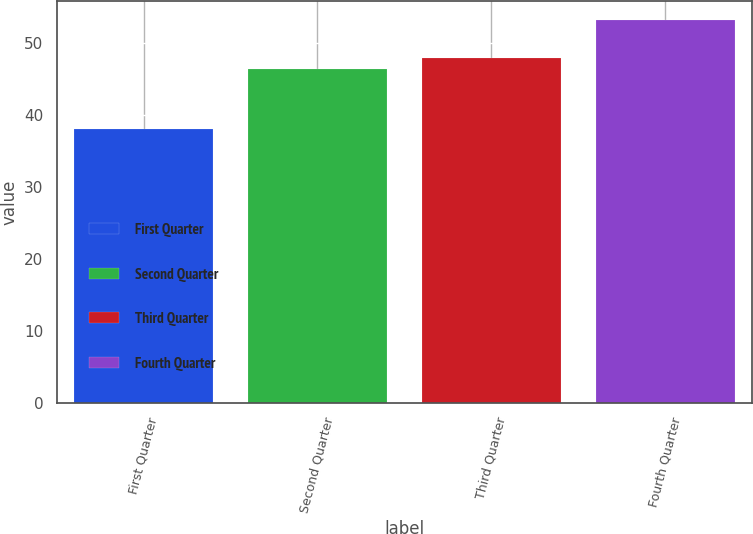Convert chart. <chart><loc_0><loc_0><loc_500><loc_500><bar_chart><fcel>First Quarter<fcel>Second Quarter<fcel>Third Quarter<fcel>Fourth Quarter<nl><fcel>37.99<fcel>46.41<fcel>47.93<fcel>53.17<nl></chart> 